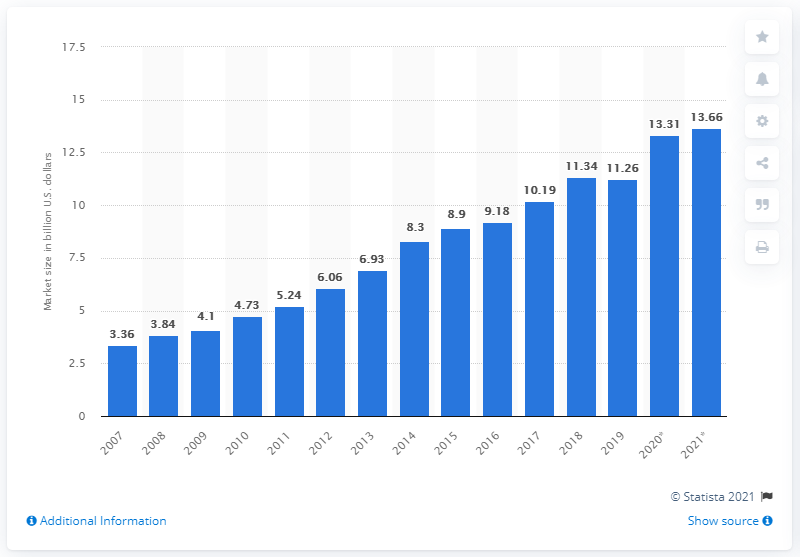Outline some significant characteristics in this image. The estimated value of India's television industry in 2021 was 13.66 